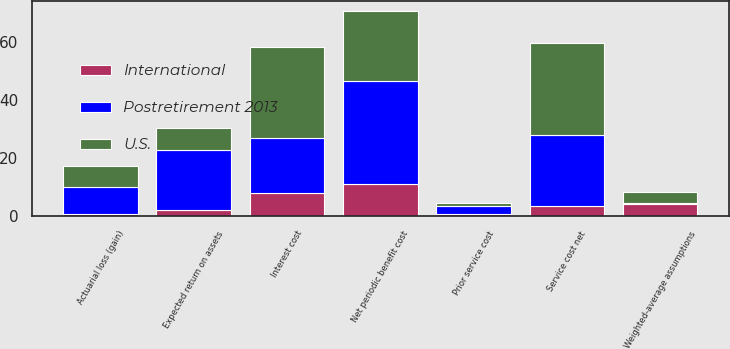Convert chart. <chart><loc_0><loc_0><loc_500><loc_500><stacked_bar_chart><ecel><fcel>Service cost net<fcel>Interest cost<fcel>Expected return on assets<fcel>Actuarial loss (gain)<fcel>Prior service cost<fcel>Net periodic benefit cost<fcel>Weighted-average assumptions<nl><fcel>U.S.<fcel>31.6<fcel>31.2<fcel>7.7<fcel>7.4<fcel>0.7<fcel>24.1<fcel>3.6<nl><fcel>Postretirement 2013<fcel>24.8<fcel>19.1<fcel>20.8<fcel>9.2<fcel>2.9<fcel>35.8<fcel>0.5<nl><fcel>International<fcel>3.4<fcel>8<fcel>2<fcel>0.8<fcel>0.8<fcel>11<fcel>4.1<nl></chart> 